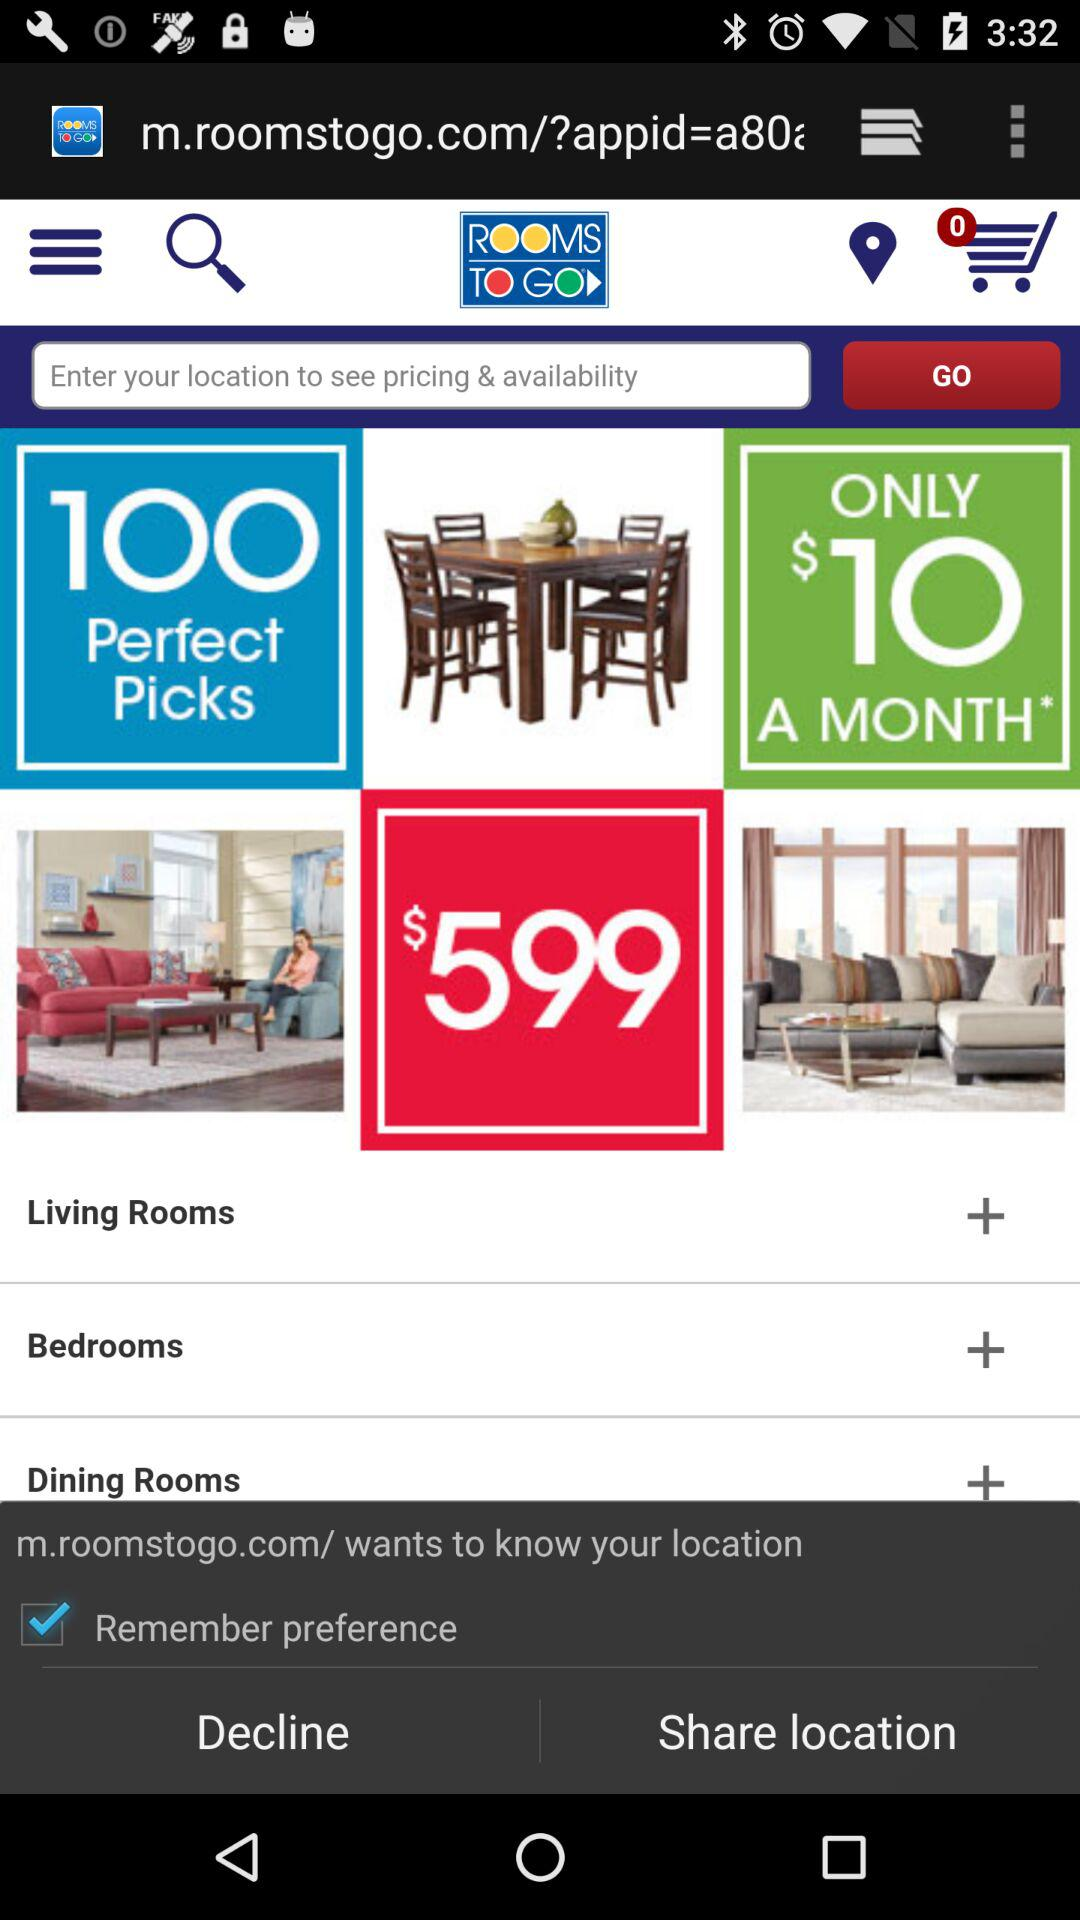What is the status of the "Remember preference"? The status of the "Remember preference" is "on". 